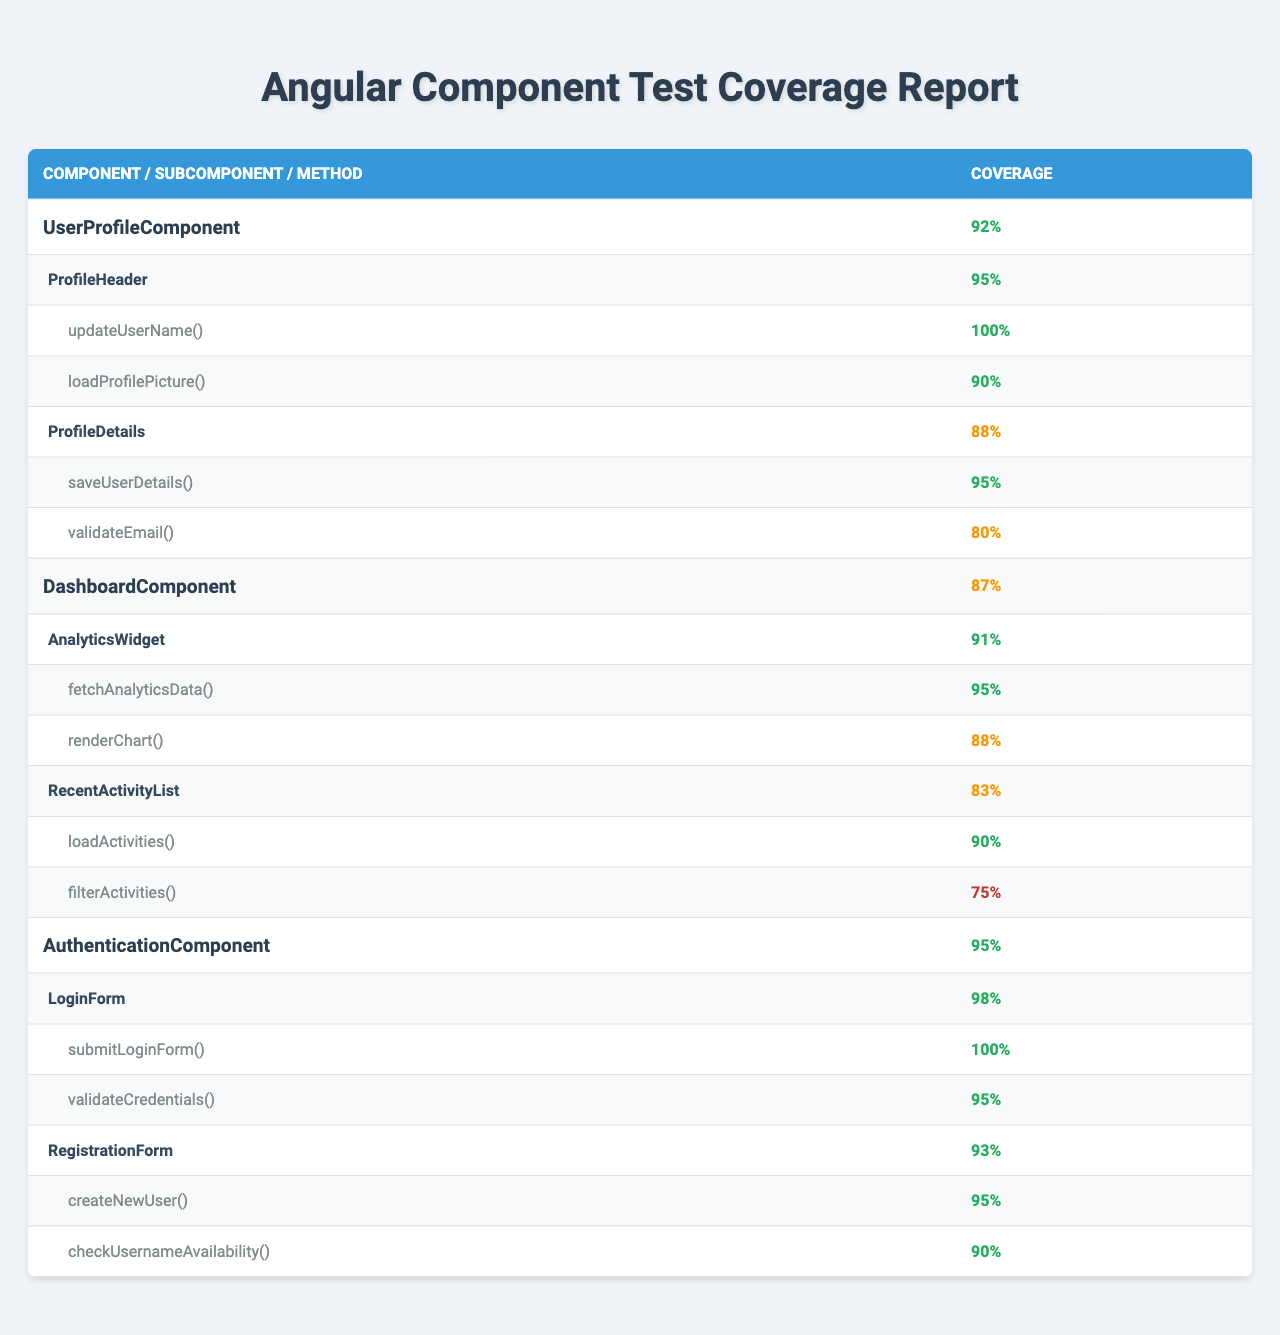What is the overall coverage of the AuthenticationComponent? The table lists the overall coverage for each component. For the AuthenticationComponent, it shows 95%.
Answer: 95% Which component has the highest overall coverage? Comparing the overall coverage percentages listed for each component, the AuthenticationComponent at 95% has the highest.
Answer: AuthenticationComponent What is the coverage percentage for the ProfileDetails subcomponent? The table specifies that the ProfileDetails subcomponent under UserProfileComponent has a coverage of 88%.
Answer: 88% What is the average coverage of the tested methods in AnalyticsWidget? The tested methods in AnalyticsWidget are fetchAnalyticsData (95%) and renderChart (88%). To find the average: (95 + 88) / 2 = 91.5%.
Answer: 91.5% Which method has the lowest coverage in the UserProfileComponent? The methods tested under the subcomponents: ProfileHeader (90% for loadProfilePicture) and ProfileDetails (80% for validateEmail). The lowest is validateEmail at 80%.
Answer: validateEmail Is the coverage of RecentActivityList greater than or equal to the coverage of ProfileDetails? The coverage for RecentActivityList is 83%, and for ProfileDetails, it is 88%. Since 83% is less than 88%, the statement is false.
Answer: No What is the difference between the highest and lowest coverage among all subcomponents? The highest subcomponent coverage is from LoginForm at 98% and the lowest is from RecentActivityList at 83%. The difference is: 98% - 83% = 15%.
Answer: 15% Which method in the LoginForm has achieved full coverage? The table shows that the method submitLoginForm in the LoginForm has a coverage of 100%, indicating full coverage.
Answer: submitLoginForm How does the overall coverage of DashboardComponent compare with UserProfileComponent? The overall coverage of DashboardComponent is 87%, while UserProfileComponent's is 92%. Since 87% is less than 92%, DashboardComponent has lower coverage.
Answer: Lower What is the total number of methods tested in the AuthenticationComponent? The AuthenticationComponent has two subcomponents: LoginForm with 2 methods and RegistrationForm also with 2 methods. Therefore, the total is 2 + 2 = 4 methods.
Answer: 4 